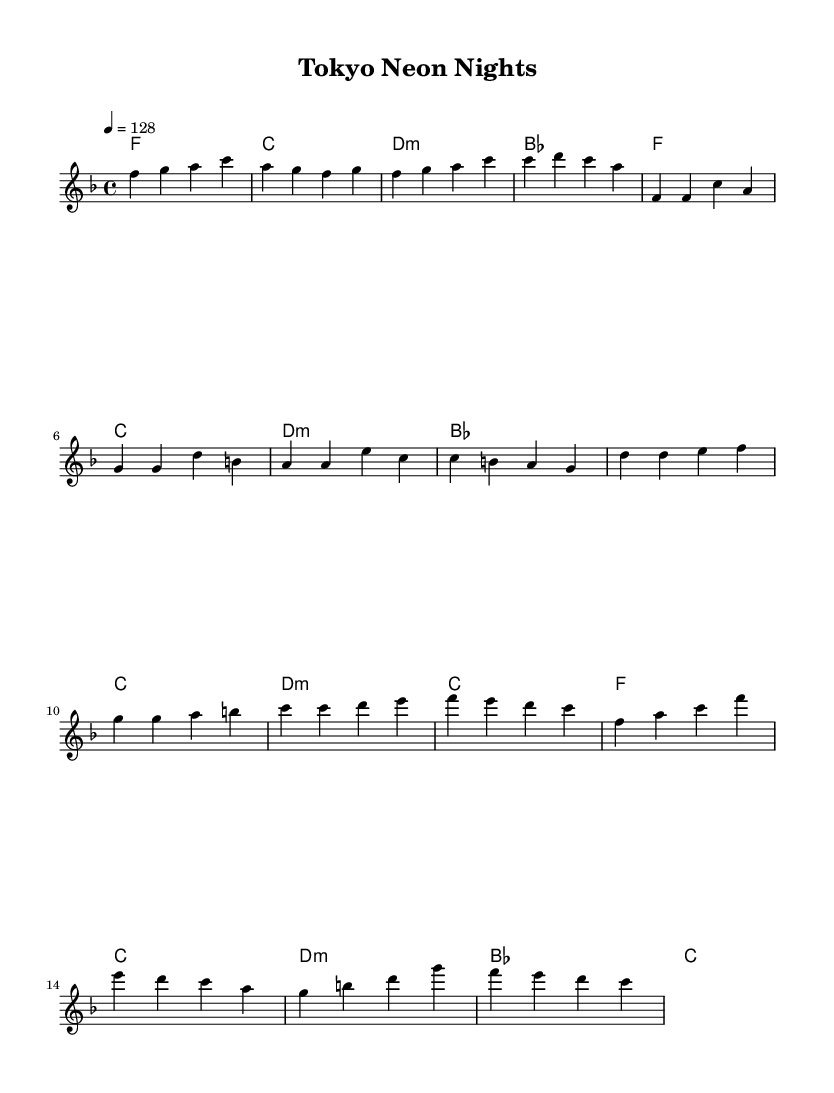What is the key signature of this music? The key signature is F major, which has one flat (B flat). This can be identified by looking at the key signature at the beginning of the staff.
Answer: F major What is the time signature of this music? The time signature is 4/4, indicated at the beginning of the score. It is represented by the numbers, where the top number denotes four beats per measure and the bottom number indicates a quarter note as the beat unit.
Answer: 4/4 What is the tempo of this music? The tempo is 128 beats per minute, specified at the beginning of the music with the marking "4 = 128". This shows the number of beats in each measure and the speed at which the song should be played.
Answer: 128 How many measures are in the chorus section? The chorus consists of four measures, identifiable in the sheet music where the melody and harmonies align under the "Chorus" labeled section. Each line represents one measure, leading to a total of four.
Answer: 4 Which chords are used in the pre-chorus section? The chords used in the pre-chorus are B flat, C, D minor, and C. This can be seen by checking the chord names written above the corresponding melody notes in the pre-chorus section of the score.
Answer: B flat, C, D minor, C How does the structure of this piece reflect typical dance music? The structure includes distinct sections like Intro, Verse, Pre-Chorus, and Chorus, which is common in dance music for build-up and release of energy. Each section serves a specific function in developing the overall flow and excitement of the piece, which is fundamental in upbeat dance tracks.
Answer: Distinct sections 